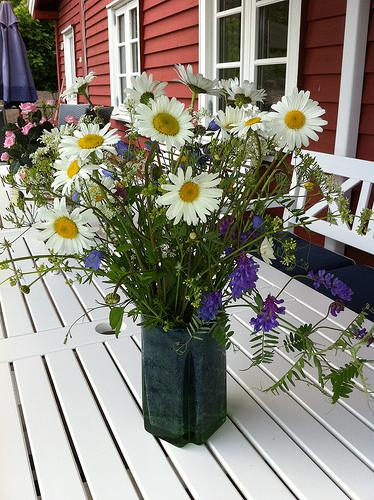Question: what is in the middle of the photo?
Choices:
A. A tree.
B. Bushes.
C. A fountain.
D. Flowers.
Answer with the letter. Answer: D Question: what color is the umbrella?
Choices:
A. Blue.
B. Black.
C. Purple.
D. Yellow.
Answer with the letter. Answer: C 